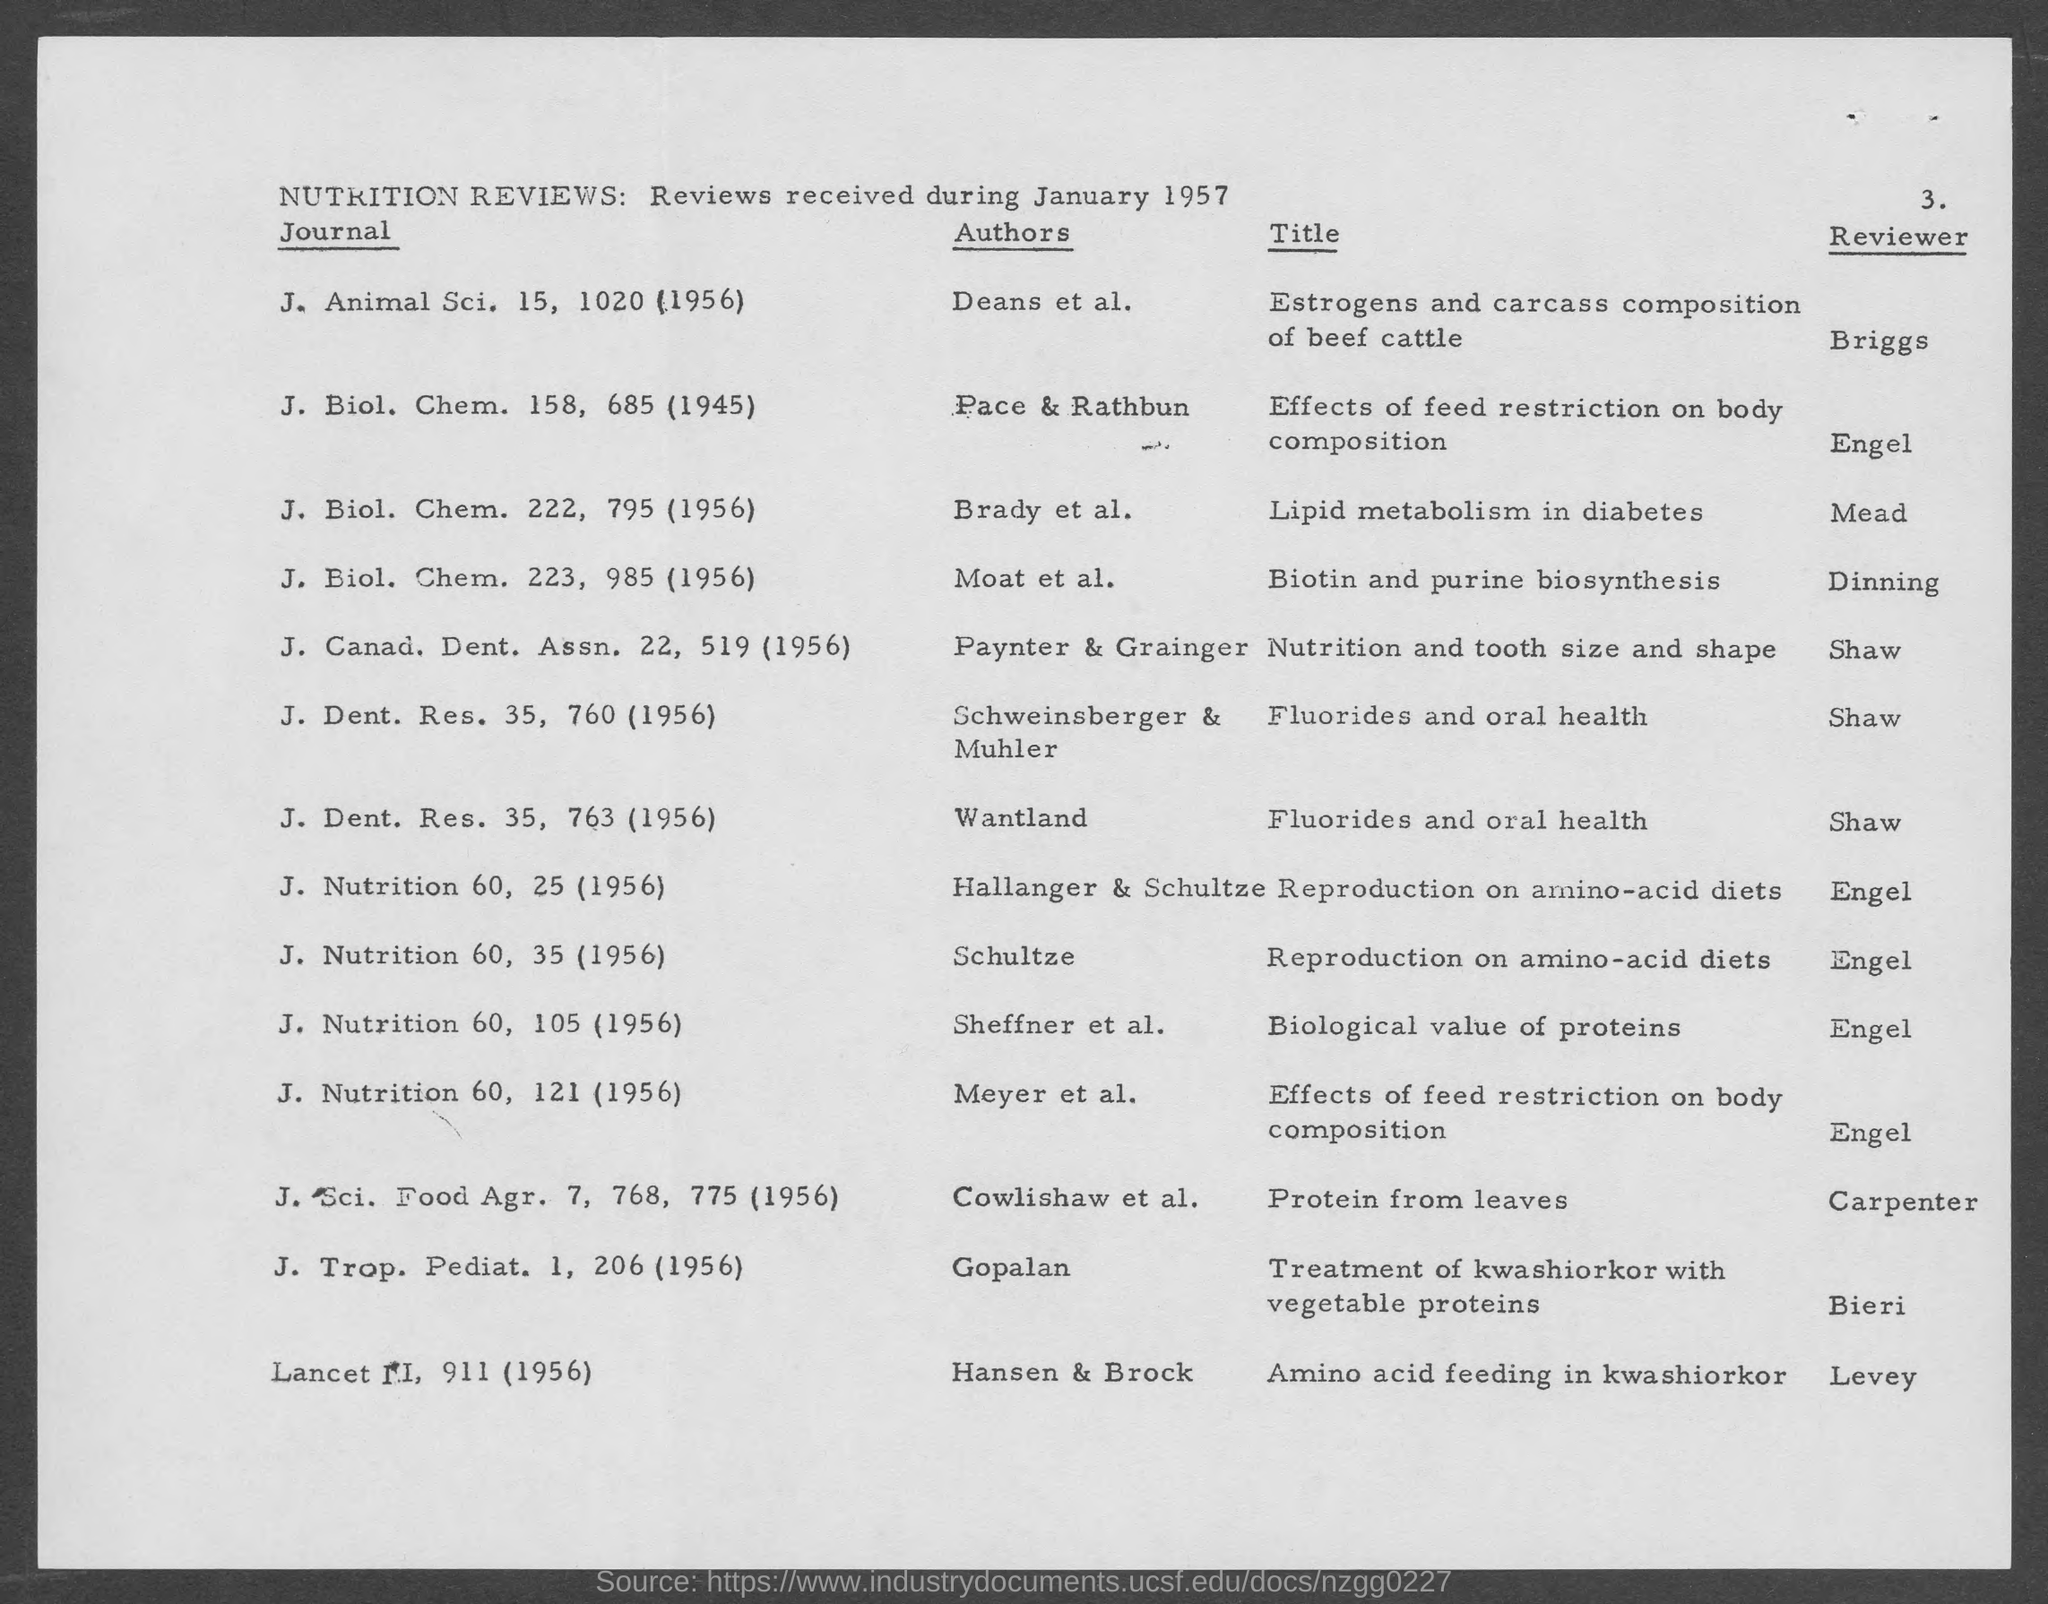What research topics are covered in the January 1957 Nutrition Reviews? The Nutrition Reviews from January 1957 covers research topics such as estrogen's effects on carcass composition, lipid metabolism in diabetes, nutrition related to tooth size and shape, fluorides' impact on oral health, reproduction on amino-acid diets, and the biological value of proteins, among others.  Are there any authors that appear more than once on this list? Yes, according to the document, the author Engel appears to have reviewed more than one article—they are listed as the reviewer for topics on reproduction on amino-acid diets and the effects of feed restriction on body composition. 